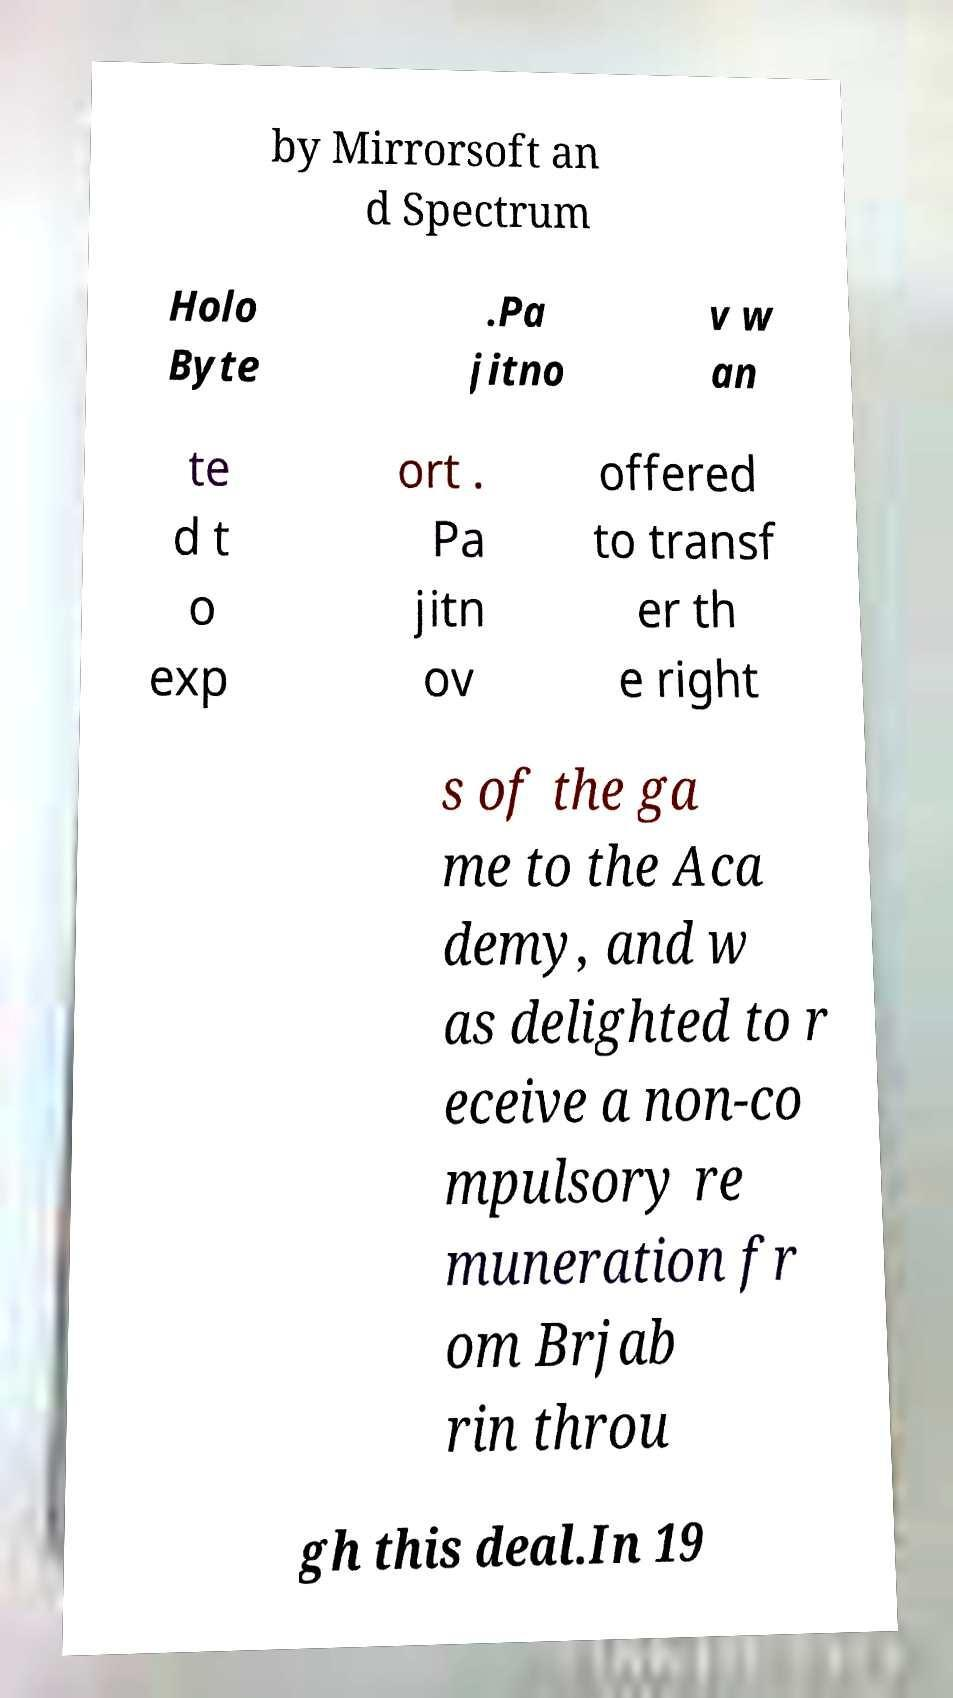Please identify and transcribe the text found in this image. by Mirrorsoft an d Spectrum Holo Byte .Pa jitno v w an te d t o exp ort . Pa jitn ov offered to transf er th e right s of the ga me to the Aca demy, and w as delighted to r eceive a non-co mpulsory re muneration fr om Brjab rin throu gh this deal.In 19 